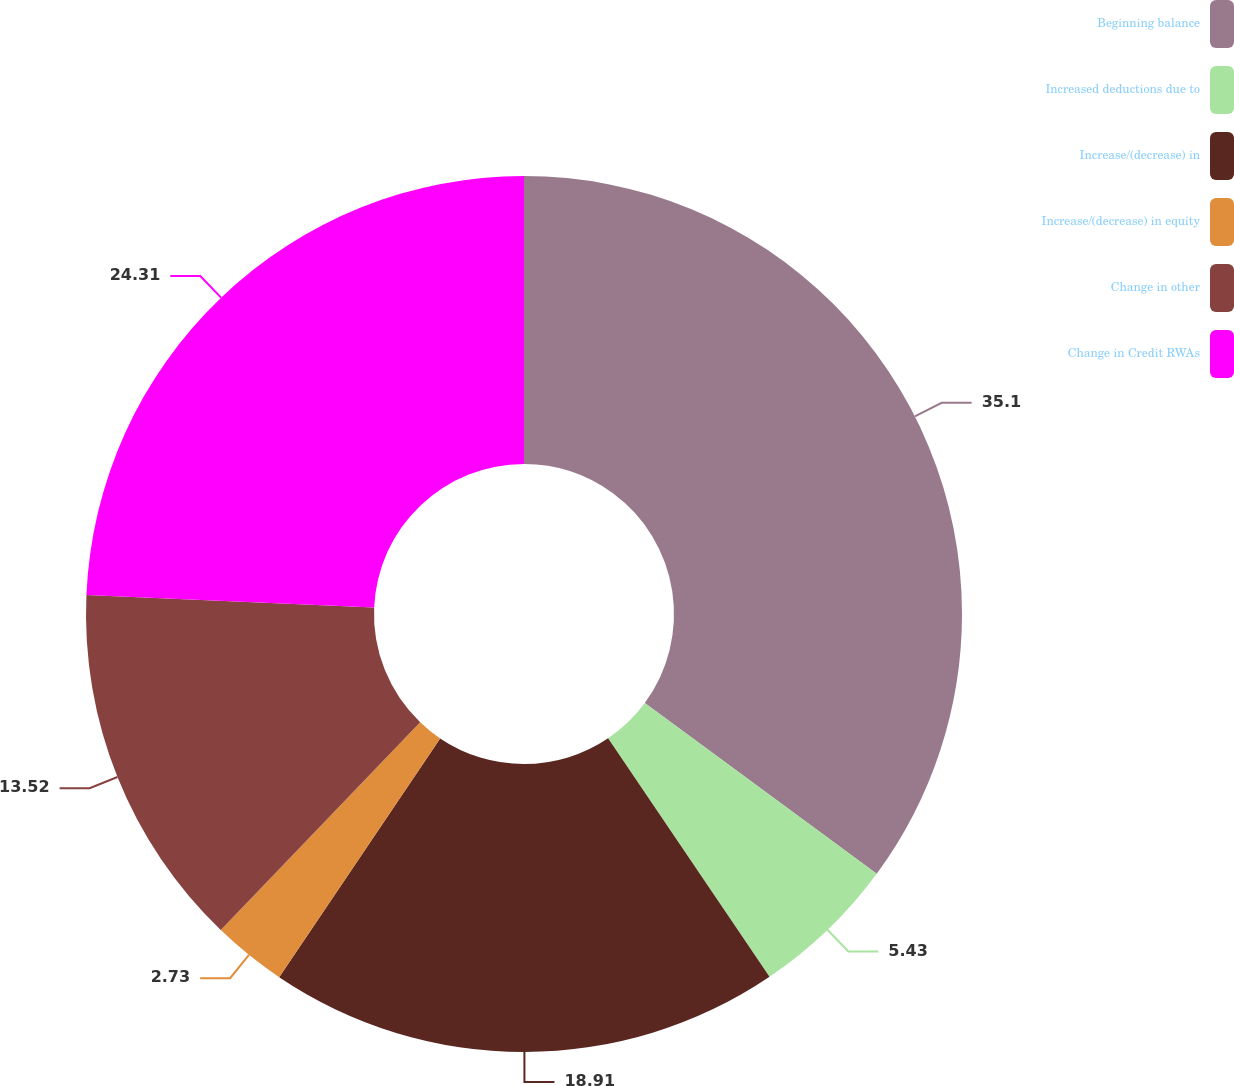Convert chart to OTSL. <chart><loc_0><loc_0><loc_500><loc_500><pie_chart><fcel>Beginning balance<fcel>Increased deductions due to<fcel>Increase/(decrease) in<fcel>Increase/(decrease) in equity<fcel>Change in other<fcel>Change in Credit RWAs<nl><fcel>35.1%<fcel>5.43%<fcel>18.91%<fcel>2.73%<fcel>13.52%<fcel>24.31%<nl></chart> 